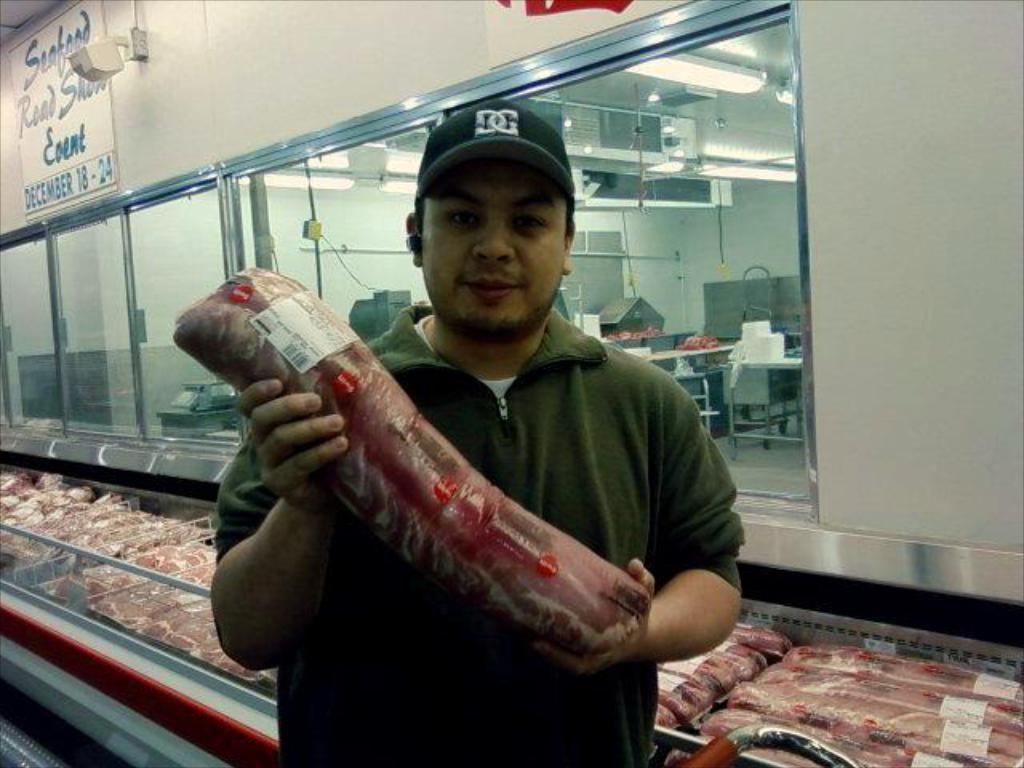What is the man in the image wearing on his head? The man is wearing a cap in the image. What is the man holding in his hands? The man is holding a packet in his hands. What can be seen in the background of the image? There are packets, glass windows, posters, lights, and some objects visible in the background of the image. What type of cushion is the man sitting on in the image? There is no cushion present in the image, and the man is not sitting on anything. 